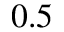Convert formula to latex. <formula><loc_0><loc_0><loc_500><loc_500>0 . 5</formula> 